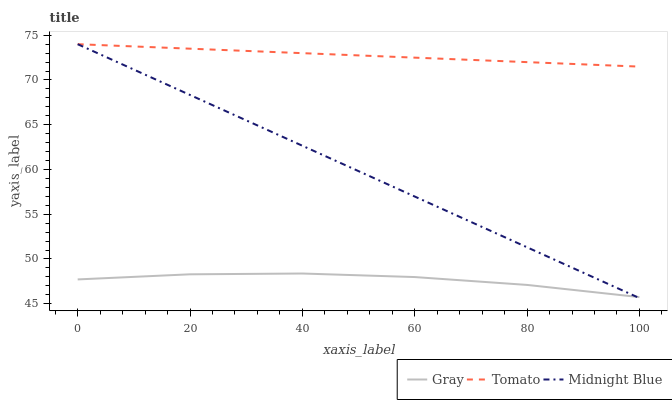Does Gray have the minimum area under the curve?
Answer yes or no. Yes. Does Tomato have the maximum area under the curve?
Answer yes or no. Yes. Does Midnight Blue have the minimum area under the curve?
Answer yes or no. No. Does Midnight Blue have the maximum area under the curve?
Answer yes or no. No. Is Tomato the smoothest?
Answer yes or no. Yes. Is Gray the roughest?
Answer yes or no. Yes. Is Midnight Blue the smoothest?
Answer yes or no. No. Is Midnight Blue the roughest?
Answer yes or no. No. Does Midnight Blue have the lowest value?
Answer yes or no. Yes. Does Gray have the lowest value?
Answer yes or no. No. Does Midnight Blue have the highest value?
Answer yes or no. Yes. Does Gray have the highest value?
Answer yes or no. No. Is Gray less than Tomato?
Answer yes or no. Yes. Is Tomato greater than Gray?
Answer yes or no. Yes. Does Midnight Blue intersect Tomato?
Answer yes or no. Yes. Is Midnight Blue less than Tomato?
Answer yes or no. No. Is Midnight Blue greater than Tomato?
Answer yes or no. No. Does Gray intersect Tomato?
Answer yes or no. No. 